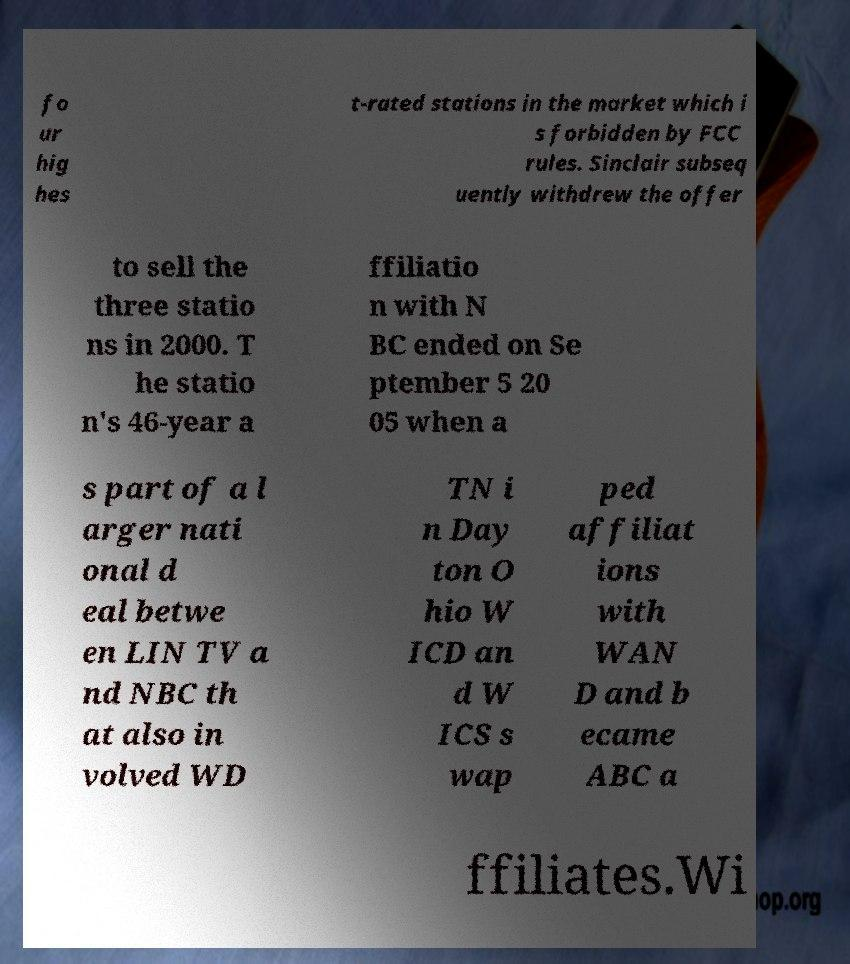Can you read and provide the text displayed in the image?This photo seems to have some interesting text. Can you extract and type it out for me? fo ur hig hes t-rated stations in the market which i s forbidden by FCC rules. Sinclair subseq uently withdrew the offer to sell the three statio ns in 2000. T he statio n's 46-year a ffiliatio n with N BC ended on Se ptember 5 20 05 when a s part of a l arger nati onal d eal betwe en LIN TV a nd NBC th at also in volved WD TN i n Day ton O hio W ICD an d W ICS s wap ped affiliat ions with WAN D and b ecame ABC a ffiliates.Wi 